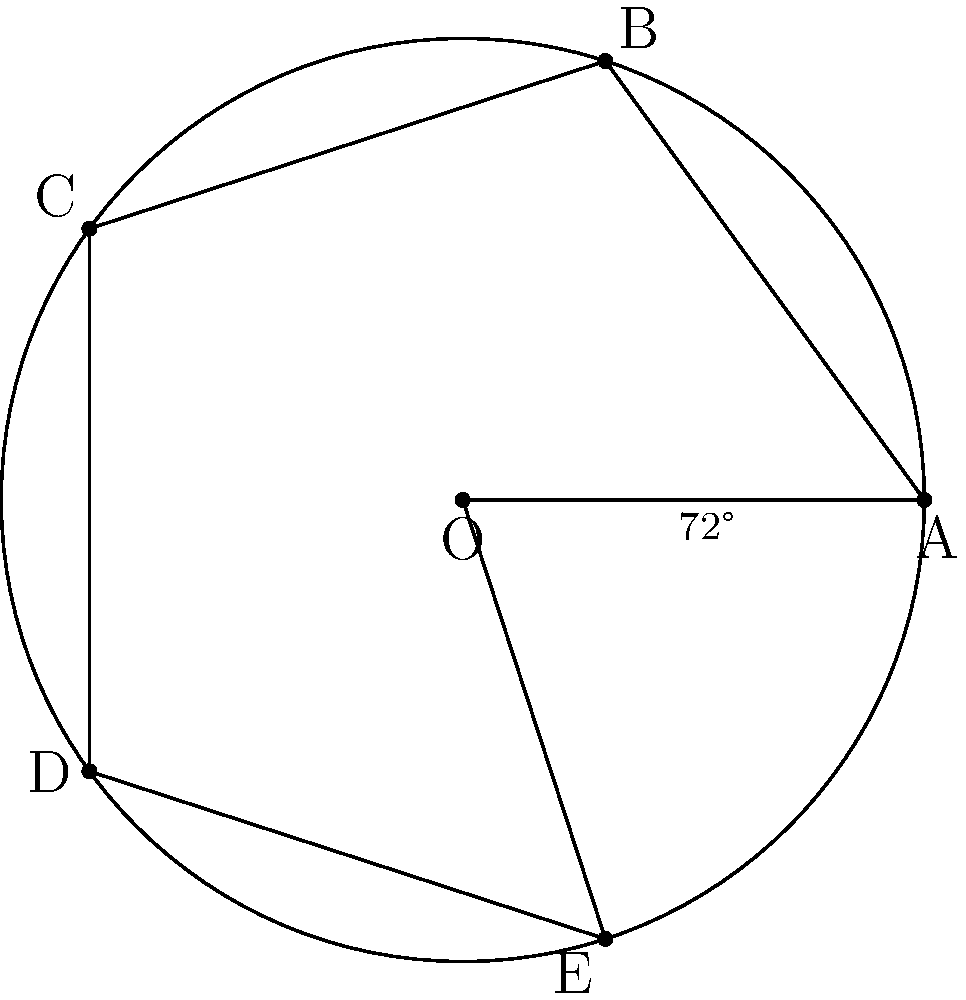As an amateur photographer interested in capturing the beauty of plants, you've noticed a fascinating leaf arrangement on a flower. The leaves form a perfect pentagonal shape around the center of the flower. If the angle between each leaf is consistent and the arrangement completes a full 360° rotation, what is the angle between each leaf? To solve this problem, let's follow these steps:

1) First, recall that a full rotation is 360°.

2) The leaves form a pentagonal shape, which means there are 5 equal segments in the rotation.

3) To find the angle between each leaf, we need to divide the total rotation by the number of segments:

   $$ \text{Angle between leaves} = \frac{\text{Total rotation}}{\text{Number of segments}} $$

4) Substituting the values:

   $$ \text{Angle between leaves} = \frac{360°}{5} $$

5) Performing the division:

   $$ \text{Angle between leaves} = 72° $$

This result matches the diagram, where each central angle of the pentagon is labeled as 72°.
Answer: 72° 